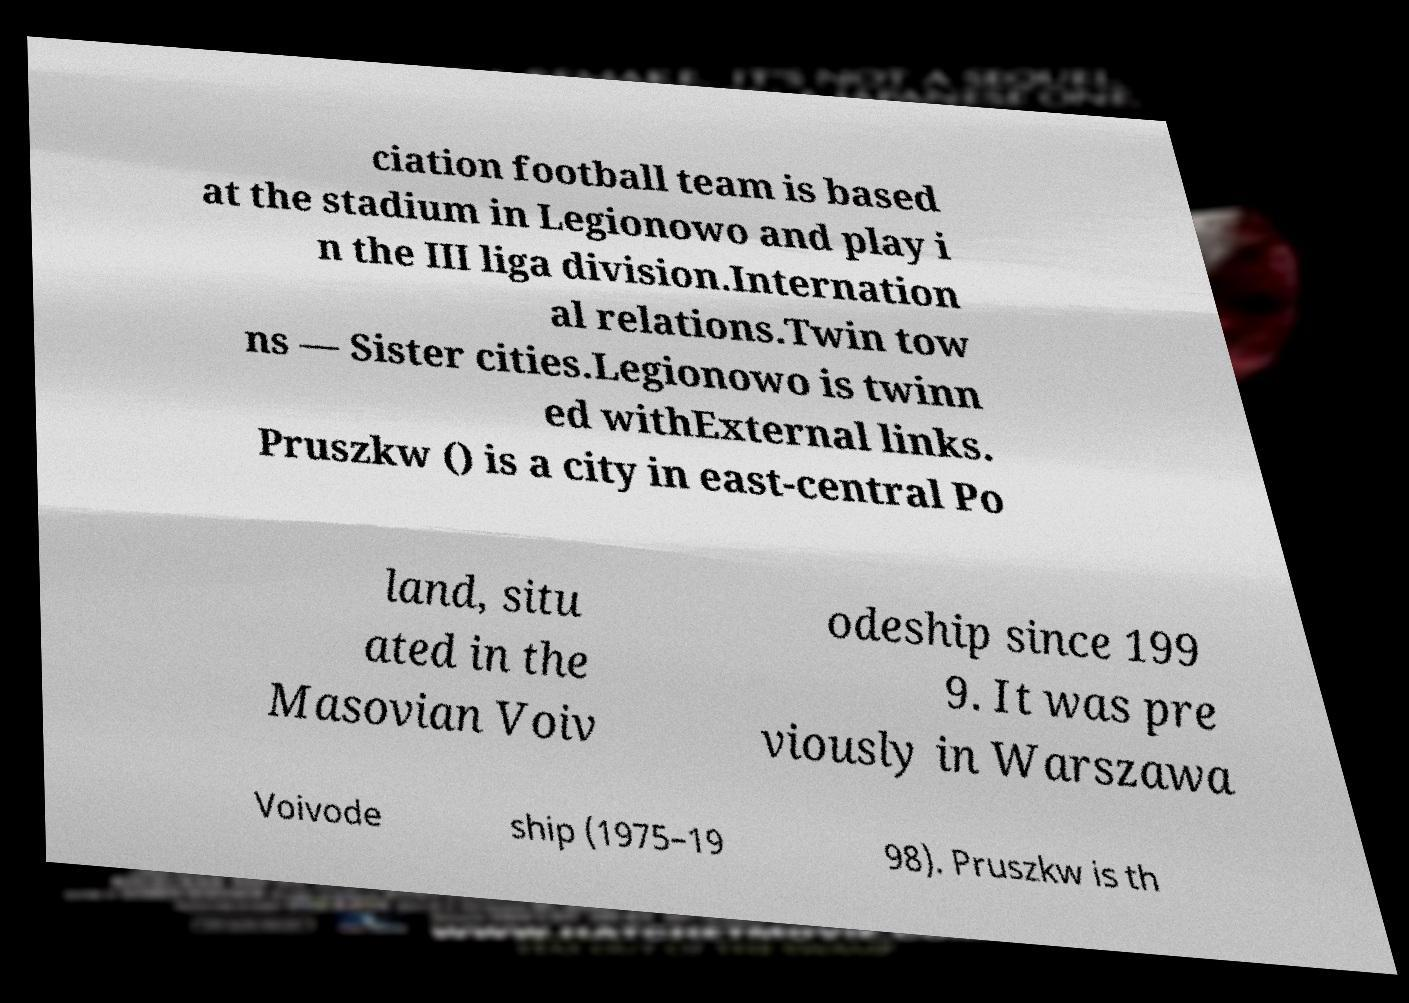Could you assist in decoding the text presented in this image and type it out clearly? ciation football team is based at the stadium in Legionowo and play i n the III liga division.Internation al relations.Twin tow ns — Sister cities.Legionowo is twinn ed withExternal links. Pruszkw () is a city in east-central Po land, situ ated in the Masovian Voiv odeship since 199 9. It was pre viously in Warszawa Voivode ship (1975–19 98). Pruszkw is th 